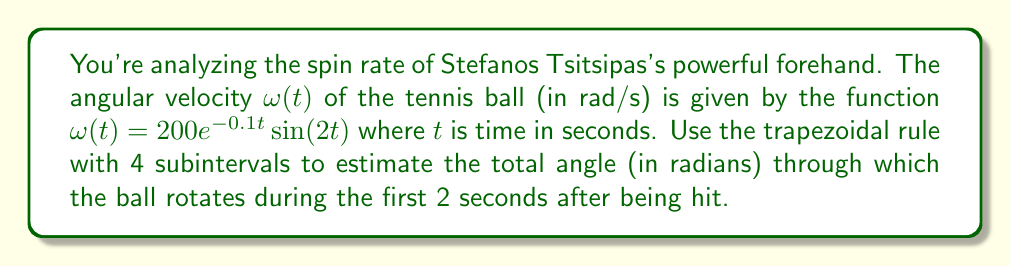Can you answer this question? To solve this problem, we'll use the trapezoidal rule for numerical integration. The steps are as follows:

1) The total angle rotated is the integral of angular velocity over time:

   $$\theta = \int_0^2 \omega(t) dt = \int_0^2 200e^{-0.1t}\sin(2t) dt$$

2) For the trapezoidal rule with 4 subintervals, we need to calculate $\omega(t)$ at 5 points: $t = 0, 0.5, 1, 1.5, 2$

3) Calculate $\omega(t)$ at these points:
   
   $\omega(0) = 200e^{-0.1(0)}\sin(2(0)) = 0$
   
   $\omega(0.5) = 200e^{-0.1(0.5)}\sin(2(0.5)) \approx 190.0332$
   
   $\omega(1) = 200e^{-0.1(1)}\sin(2(1)) \approx 145.0516$
   
   $\omega(1.5) = 200e^{-0.1(1.5)}\sin(2(1.5)) \approx -70.7372$
   
   $\omega(2) = 200e^{-0.1(2)}\sin(2(2)) \approx -164.8721$

4) Apply the trapezoidal rule formula:

   $$\int_a^b f(x)dx \approx \frac{h}{2}[f(x_0) + 2f(x_1) + 2f(x_2) + ... + 2f(x_{n-1}) + f(x_n)]$$

   Where $h = \frac{b-a}{n} = \frac{2-0}{4} = 0.5$

5) Substitute the values:

   $$\theta \approx \frac{0.5}{2}[0 + 2(190.0332) + 2(145.0516) + 2(-70.7372) + (-164.8721)]$$

6) Compute:

   $$\theta \approx 0.25[0 + 380.0664 + 290.1032 - 141.4744 - 164.8721] = 90.9558$$

Therefore, the estimated total angle through which the ball rotates is approximately 90.9558 radians.
Answer: 90.9558 radians 